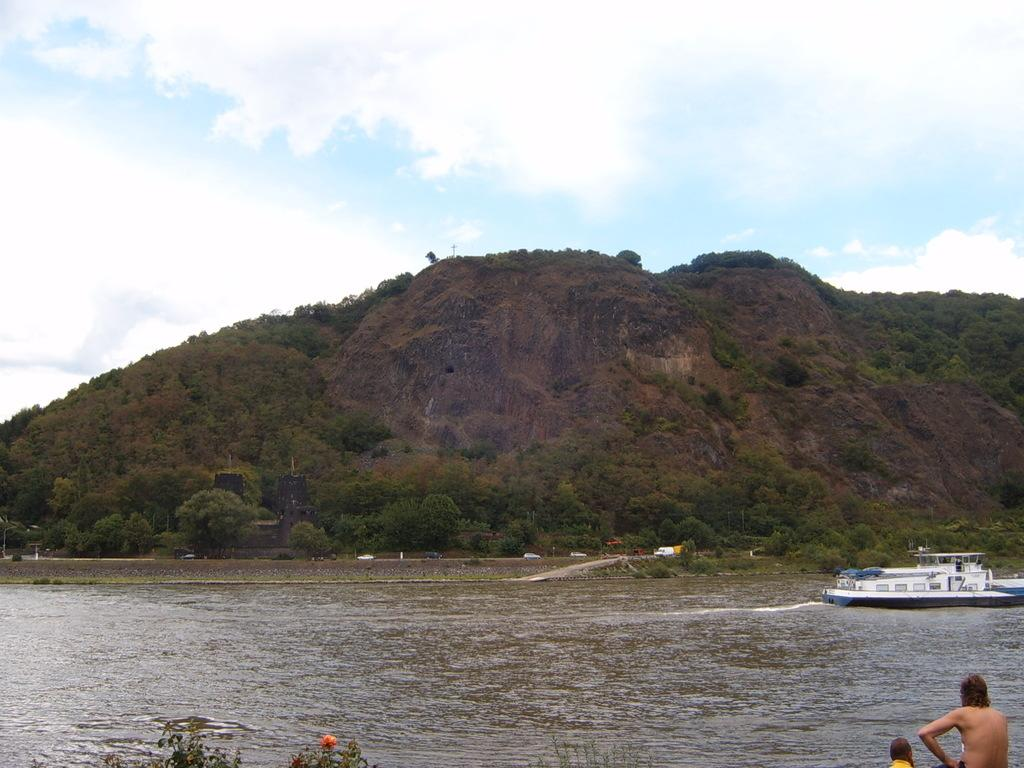What is the main subject of the image? The main subject of the image is a boat. What is the boat doing in the image? The boat is sailing on the water in the image. Are there any people visible in the image? Yes, there are humans in the image. What type of natural environment can be seen in the image? There are trees and a hill visible in the image. How would you describe the sky in the image? The sky is blue and cloudy in the image. What type of floor can be seen in the image? There is no floor present in the image, as it features a boat sailing on the water. 